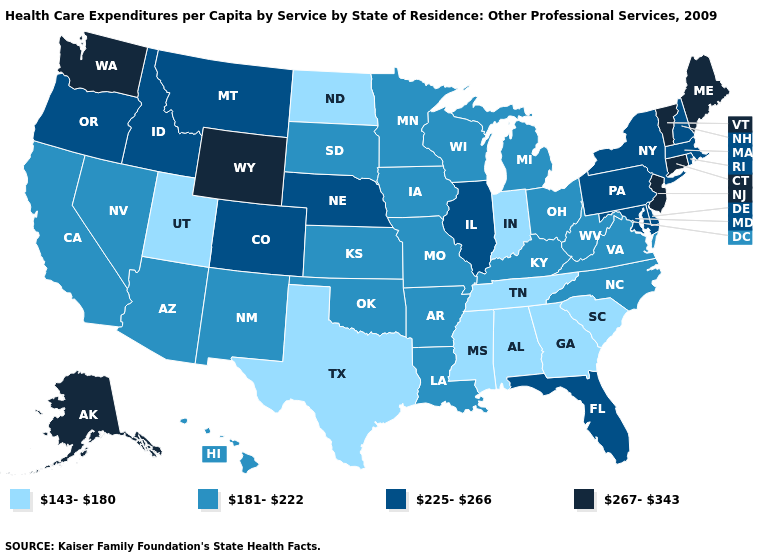Name the states that have a value in the range 181-222?
Keep it brief. Arizona, Arkansas, California, Hawaii, Iowa, Kansas, Kentucky, Louisiana, Michigan, Minnesota, Missouri, Nevada, New Mexico, North Carolina, Ohio, Oklahoma, South Dakota, Virginia, West Virginia, Wisconsin. What is the highest value in the USA?
Concise answer only. 267-343. How many symbols are there in the legend?
Answer briefly. 4. Does Massachusetts have the same value as Indiana?
Keep it brief. No. What is the value of Washington?
Write a very short answer. 267-343. What is the lowest value in the West?
Short answer required. 143-180. What is the highest value in the USA?
Keep it brief. 267-343. Name the states that have a value in the range 267-343?
Short answer required. Alaska, Connecticut, Maine, New Jersey, Vermont, Washington, Wyoming. What is the value of Washington?
Answer briefly. 267-343. Does Arkansas have a higher value than Texas?
Concise answer only. Yes. What is the lowest value in states that border California?
Quick response, please. 181-222. Which states have the lowest value in the USA?
Concise answer only. Alabama, Georgia, Indiana, Mississippi, North Dakota, South Carolina, Tennessee, Texas, Utah. Name the states that have a value in the range 143-180?
Quick response, please. Alabama, Georgia, Indiana, Mississippi, North Dakota, South Carolina, Tennessee, Texas, Utah. What is the value of Louisiana?
Give a very brief answer. 181-222. Which states have the lowest value in the USA?
Concise answer only. Alabama, Georgia, Indiana, Mississippi, North Dakota, South Carolina, Tennessee, Texas, Utah. 